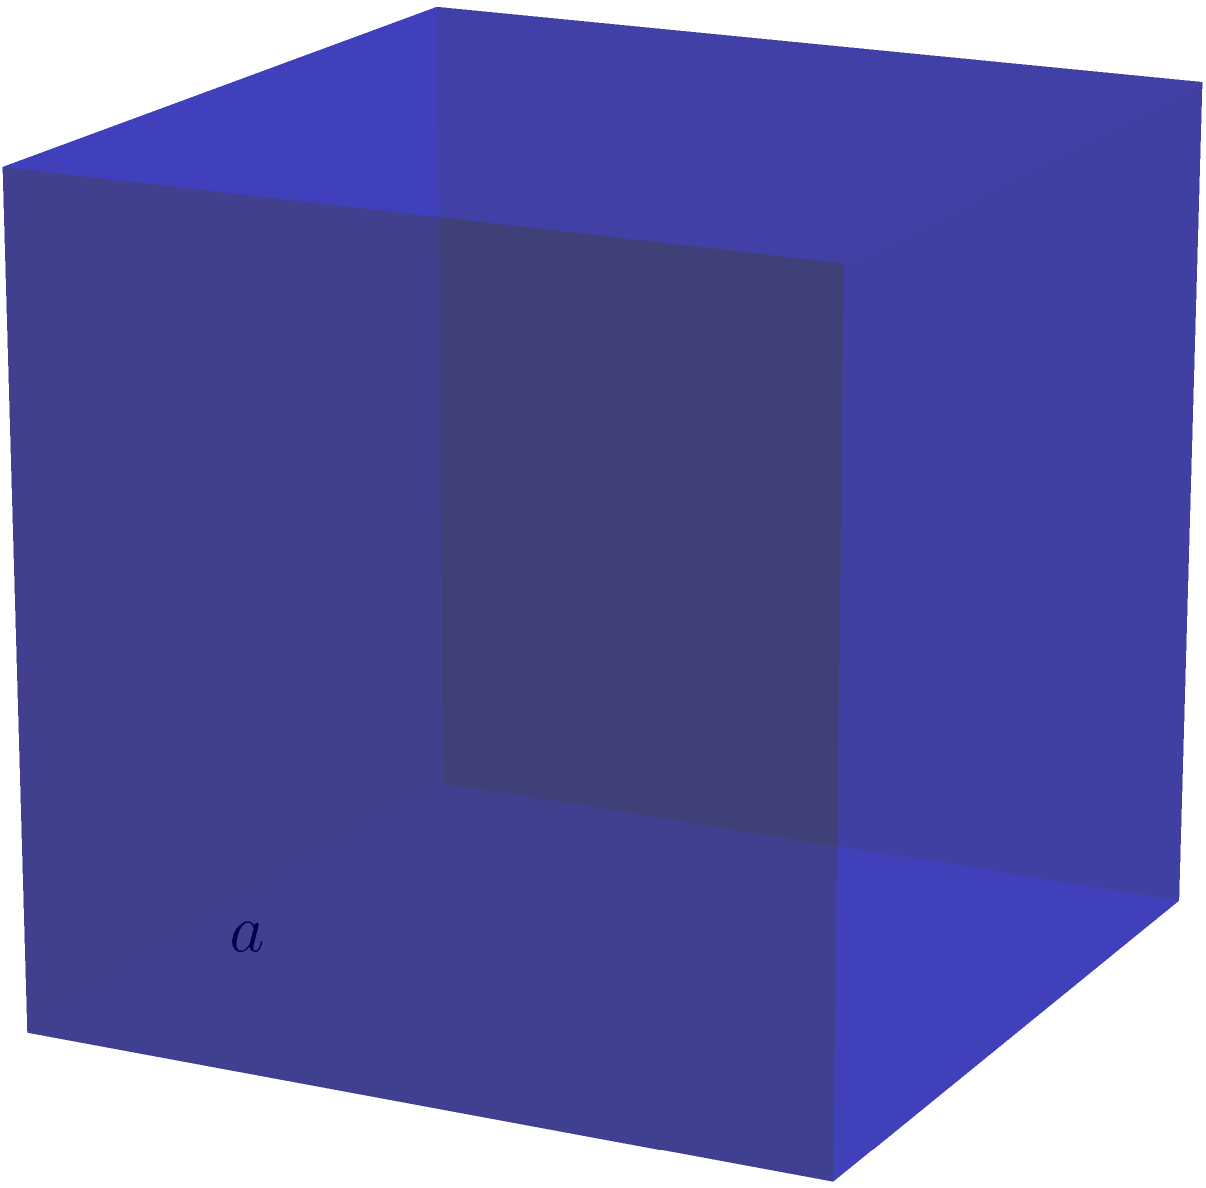As an arcane focus, you've acquired a cube-shaped gem with a side length of 4 inches. To enhance its magical properties, you need to inscribe runes on its entire surface. What is the total surface area of the gem that you need to cover with runes? Let's approach this step-by-step:

1) The formula for the surface area of a cube is $SA = 6a^2$, where $a$ is the length of one side.

2) We're given that the side length is 4 inches.

3) Let's substitute this into our formula:
   $SA = 6 \cdot (4 \text{ in})^2$

4) First, let's calculate the square:
   $(4 \text{ in})^2 = 16 \text{ in}^2$

5) Now, we multiply by 6:
   $SA = 6 \cdot 16 \text{ in}^2 = 96 \text{ in}^2$

Therefore, the total surface area of the cube-shaped gem is 96 square inches.
Answer: $96 \text{ in}^2$ 